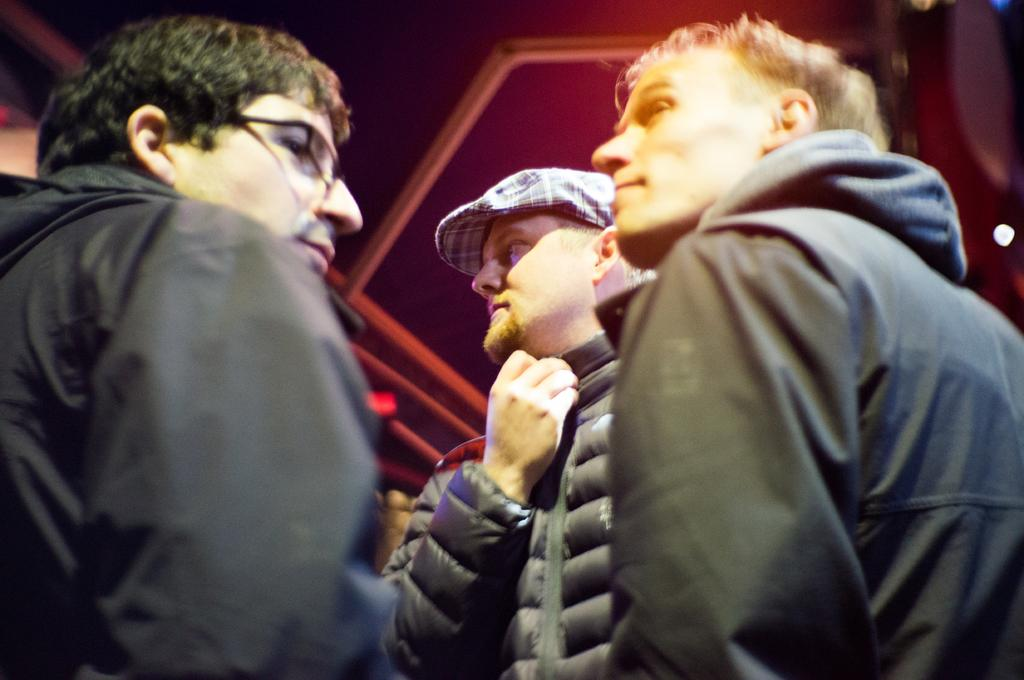How many people are present in the image? There are three persons in the image. What type of industry can be seen in the background of the image? There is no industry visible in the image; it only features three persons. What is the voice of the grandmother in the image? There is no mention of a grandmother or any voice in the image. 